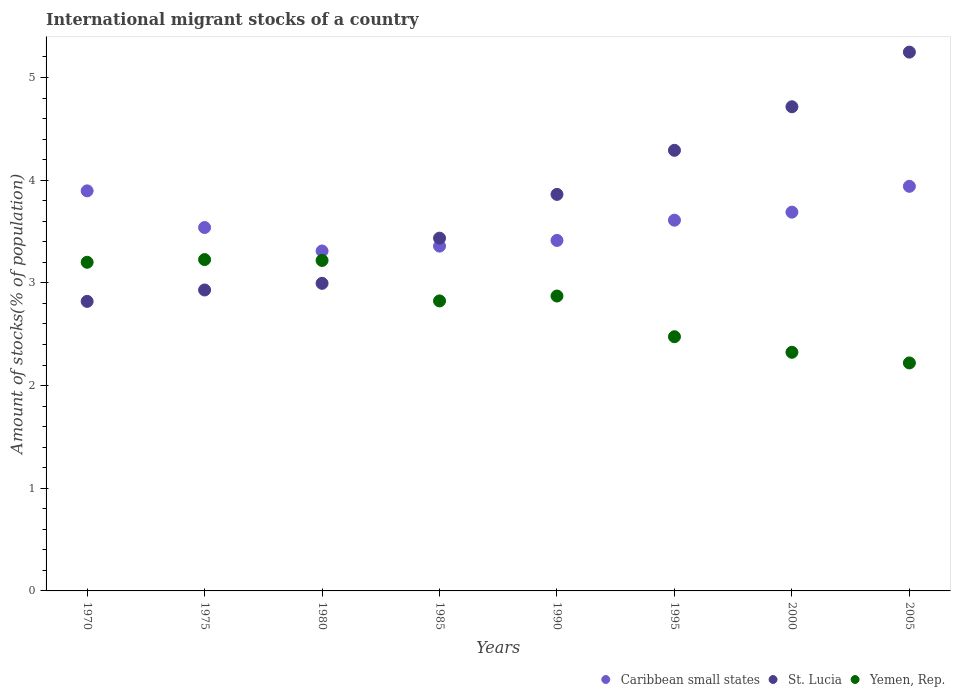How many different coloured dotlines are there?
Offer a terse response. 3. What is the amount of stocks in in Caribbean small states in 1990?
Your answer should be compact. 3.41. Across all years, what is the maximum amount of stocks in in St. Lucia?
Offer a terse response. 5.25. Across all years, what is the minimum amount of stocks in in Yemen, Rep.?
Offer a very short reply. 2.22. In which year was the amount of stocks in in Yemen, Rep. maximum?
Your answer should be very brief. 1975. What is the total amount of stocks in in Caribbean small states in the graph?
Provide a succinct answer. 28.75. What is the difference between the amount of stocks in in Caribbean small states in 1985 and that in 1995?
Your answer should be very brief. -0.25. What is the difference between the amount of stocks in in Caribbean small states in 1985 and the amount of stocks in in St. Lucia in 1980?
Give a very brief answer. 0.36. What is the average amount of stocks in in Caribbean small states per year?
Ensure brevity in your answer.  3.59. In the year 2005, what is the difference between the amount of stocks in in Yemen, Rep. and amount of stocks in in Caribbean small states?
Ensure brevity in your answer.  -1.72. In how many years, is the amount of stocks in in Caribbean small states greater than 1.2 %?
Your answer should be compact. 8. What is the ratio of the amount of stocks in in St. Lucia in 1975 to that in 1985?
Provide a short and direct response. 0.85. Is the amount of stocks in in St. Lucia in 1980 less than that in 2000?
Offer a terse response. Yes. Is the difference between the amount of stocks in in Yemen, Rep. in 2000 and 2005 greater than the difference between the amount of stocks in in Caribbean small states in 2000 and 2005?
Provide a short and direct response. Yes. What is the difference between the highest and the second highest amount of stocks in in Yemen, Rep.?
Your response must be concise. 0.01. What is the difference between the highest and the lowest amount of stocks in in Caribbean small states?
Your response must be concise. 0.63. In how many years, is the amount of stocks in in Yemen, Rep. greater than the average amount of stocks in in Yemen, Rep. taken over all years?
Ensure brevity in your answer.  5. Is the sum of the amount of stocks in in St. Lucia in 1970 and 1990 greater than the maximum amount of stocks in in Yemen, Rep. across all years?
Make the answer very short. Yes. Does the amount of stocks in in St. Lucia monotonically increase over the years?
Keep it short and to the point. Yes. Is the amount of stocks in in St. Lucia strictly less than the amount of stocks in in Yemen, Rep. over the years?
Offer a very short reply. No. How many years are there in the graph?
Offer a very short reply. 8. What is the difference between two consecutive major ticks on the Y-axis?
Your answer should be compact. 1. Are the values on the major ticks of Y-axis written in scientific E-notation?
Your answer should be compact. No. Does the graph contain any zero values?
Your response must be concise. No. Does the graph contain grids?
Offer a terse response. No. Where does the legend appear in the graph?
Provide a short and direct response. Bottom right. What is the title of the graph?
Provide a succinct answer. International migrant stocks of a country. Does "High income: OECD" appear as one of the legend labels in the graph?
Ensure brevity in your answer.  No. What is the label or title of the X-axis?
Offer a very short reply. Years. What is the label or title of the Y-axis?
Provide a succinct answer. Amount of stocks(% of population). What is the Amount of stocks(% of population) in Caribbean small states in 1970?
Provide a short and direct response. 3.9. What is the Amount of stocks(% of population) in St. Lucia in 1970?
Keep it short and to the point. 2.82. What is the Amount of stocks(% of population) in Yemen, Rep. in 1970?
Ensure brevity in your answer.  3.2. What is the Amount of stocks(% of population) in Caribbean small states in 1975?
Your answer should be compact. 3.54. What is the Amount of stocks(% of population) in St. Lucia in 1975?
Give a very brief answer. 2.93. What is the Amount of stocks(% of population) in Yemen, Rep. in 1975?
Your answer should be very brief. 3.23. What is the Amount of stocks(% of population) of Caribbean small states in 1980?
Your answer should be compact. 3.31. What is the Amount of stocks(% of population) of St. Lucia in 1980?
Offer a terse response. 3. What is the Amount of stocks(% of population) of Yemen, Rep. in 1980?
Keep it short and to the point. 3.22. What is the Amount of stocks(% of population) in Caribbean small states in 1985?
Give a very brief answer. 3.36. What is the Amount of stocks(% of population) in St. Lucia in 1985?
Provide a succinct answer. 3.44. What is the Amount of stocks(% of population) in Yemen, Rep. in 1985?
Offer a terse response. 2.82. What is the Amount of stocks(% of population) of Caribbean small states in 1990?
Make the answer very short. 3.41. What is the Amount of stocks(% of population) in St. Lucia in 1990?
Ensure brevity in your answer.  3.86. What is the Amount of stocks(% of population) in Yemen, Rep. in 1990?
Your response must be concise. 2.87. What is the Amount of stocks(% of population) in Caribbean small states in 1995?
Offer a terse response. 3.61. What is the Amount of stocks(% of population) in St. Lucia in 1995?
Ensure brevity in your answer.  4.29. What is the Amount of stocks(% of population) of Yemen, Rep. in 1995?
Your response must be concise. 2.48. What is the Amount of stocks(% of population) of Caribbean small states in 2000?
Make the answer very short. 3.69. What is the Amount of stocks(% of population) of St. Lucia in 2000?
Your answer should be very brief. 4.71. What is the Amount of stocks(% of population) of Yemen, Rep. in 2000?
Provide a succinct answer. 2.32. What is the Amount of stocks(% of population) in Caribbean small states in 2005?
Make the answer very short. 3.94. What is the Amount of stocks(% of population) of St. Lucia in 2005?
Give a very brief answer. 5.25. What is the Amount of stocks(% of population) of Yemen, Rep. in 2005?
Make the answer very short. 2.22. Across all years, what is the maximum Amount of stocks(% of population) of Caribbean small states?
Ensure brevity in your answer.  3.94. Across all years, what is the maximum Amount of stocks(% of population) in St. Lucia?
Offer a very short reply. 5.25. Across all years, what is the maximum Amount of stocks(% of population) in Yemen, Rep.?
Offer a very short reply. 3.23. Across all years, what is the minimum Amount of stocks(% of population) in Caribbean small states?
Offer a very short reply. 3.31. Across all years, what is the minimum Amount of stocks(% of population) in St. Lucia?
Your answer should be very brief. 2.82. Across all years, what is the minimum Amount of stocks(% of population) of Yemen, Rep.?
Ensure brevity in your answer.  2.22. What is the total Amount of stocks(% of population) in Caribbean small states in the graph?
Provide a short and direct response. 28.75. What is the total Amount of stocks(% of population) in St. Lucia in the graph?
Keep it short and to the point. 30.3. What is the total Amount of stocks(% of population) in Yemen, Rep. in the graph?
Make the answer very short. 22.36. What is the difference between the Amount of stocks(% of population) in Caribbean small states in 1970 and that in 1975?
Offer a terse response. 0.36. What is the difference between the Amount of stocks(% of population) in St. Lucia in 1970 and that in 1975?
Provide a succinct answer. -0.11. What is the difference between the Amount of stocks(% of population) in Yemen, Rep. in 1970 and that in 1975?
Keep it short and to the point. -0.03. What is the difference between the Amount of stocks(% of population) in Caribbean small states in 1970 and that in 1980?
Provide a succinct answer. 0.59. What is the difference between the Amount of stocks(% of population) in St. Lucia in 1970 and that in 1980?
Your response must be concise. -0.18. What is the difference between the Amount of stocks(% of population) in Yemen, Rep. in 1970 and that in 1980?
Your answer should be very brief. -0.02. What is the difference between the Amount of stocks(% of population) in Caribbean small states in 1970 and that in 1985?
Keep it short and to the point. 0.54. What is the difference between the Amount of stocks(% of population) in St. Lucia in 1970 and that in 1985?
Give a very brief answer. -0.62. What is the difference between the Amount of stocks(% of population) in Yemen, Rep. in 1970 and that in 1985?
Your answer should be compact. 0.38. What is the difference between the Amount of stocks(% of population) of Caribbean small states in 1970 and that in 1990?
Keep it short and to the point. 0.48. What is the difference between the Amount of stocks(% of population) of St. Lucia in 1970 and that in 1990?
Your answer should be very brief. -1.04. What is the difference between the Amount of stocks(% of population) of Yemen, Rep. in 1970 and that in 1990?
Provide a short and direct response. 0.33. What is the difference between the Amount of stocks(% of population) of Caribbean small states in 1970 and that in 1995?
Offer a very short reply. 0.29. What is the difference between the Amount of stocks(% of population) of St. Lucia in 1970 and that in 1995?
Your answer should be very brief. -1.47. What is the difference between the Amount of stocks(% of population) in Yemen, Rep. in 1970 and that in 1995?
Your answer should be very brief. 0.72. What is the difference between the Amount of stocks(% of population) of Caribbean small states in 1970 and that in 2000?
Offer a very short reply. 0.21. What is the difference between the Amount of stocks(% of population) in St. Lucia in 1970 and that in 2000?
Offer a very short reply. -1.9. What is the difference between the Amount of stocks(% of population) of Yemen, Rep. in 1970 and that in 2000?
Your answer should be compact. 0.88. What is the difference between the Amount of stocks(% of population) in Caribbean small states in 1970 and that in 2005?
Give a very brief answer. -0.04. What is the difference between the Amount of stocks(% of population) in St. Lucia in 1970 and that in 2005?
Give a very brief answer. -2.43. What is the difference between the Amount of stocks(% of population) of Yemen, Rep. in 1970 and that in 2005?
Provide a succinct answer. 0.98. What is the difference between the Amount of stocks(% of population) of Caribbean small states in 1975 and that in 1980?
Provide a short and direct response. 0.23. What is the difference between the Amount of stocks(% of population) of St. Lucia in 1975 and that in 1980?
Your answer should be very brief. -0.06. What is the difference between the Amount of stocks(% of population) in Yemen, Rep. in 1975 and that in 1980?
Give a very brief answer. 0.01. What is the difference between the Amount of stocks(% of population) in Caribbean small states in 1975 and that in 1985?
Provide a succinct answer. 0.18. What is the difference between the Amount of stocks(% of population) in St. Lucia in 1975 and that in 1985?
Keep it short and to the point. -0.5. What is the difference between the Amount of stocks(% of population) in Yemen, Rep. in 1975 and that in 1985?
Keep it short and to the point. 0.4. What is the difference between the Amount of stocks(% of population) in Caribbean small states in 1975 and that in 1990?
Offer a terse response. 0.13. What is the difference between the Amount of stocks(% of population) of St. Lucia in 1975 and that in 1990?
Offer a very short reply. -0.93. What is the difference between the Amount of stocks(% of population) of Yemen, Rep. in 1975 and that in 1990?
Provide a succinct answer. 0.35. What is the difference between the Amount of stocks(% of population) of Caribbean small states in 1975 and that in 1995?
Your answer should be very brief. -0.07. What is the difference between the Amount of stocks(% of population) in St. Lucia in 1975 and that in 1995?
Provide a succinct answer. -1.36. What is the difference between the Amount of stocks(% of population) of Yemen, Rep. in 1975 and that in 1995?
Provide a succinct answer. 0.75. What is the difference between the Amount of stocks(% of population) of Caribbean small states in 1975 and that in 2000?
Your response must be concise. -0.15. What is the difference between the Amount of stocks(% of population) in St. Lucia in 1975 and that in 2000?
Keep it short and to the point. -1.78. What is the difference between the Amount of stocks(% of population) in Yemen, Rep. in 1975 and that in 2000?
Your answer should be very brief. 0.9. What is the difference between the Amount of stocks(% of population) in Caribbean small states in 1975 and that in 2005?
Offer a terse response. -0.4. What is the difference between the Amount of stocks(% of population) in St. Lucia in 1975 and that in 2005?
Make the answer very short. -2.32. What is the difference between the Amount of stocks(% of population) in Yemen, Rep. in 1975 and that in 2005?
Your answer should be compact. 1.01. What is the difference between the Amount of stocks(% of population) of Caribbean small states in 1980 and that in 1985?
Your response must be concise. -0.05. What is the difference between the Amount of stocks(% of population) of St. Lucia in 1980 and that in 1985?
Provide a succinct answer. -0.44. What is the difference between the Amount of stocks(% of population) of Yemen, Rep. in 1980 and that in 1985?
Give a very brief answer. 0.39. What is the difference between the Amount of stocks(% of population) in Caribbean small states in 1980 and that in 1990?
Offer a terse response. -0.1. What is the difference between the Amount of stocks(% of population) in St. Lucia in 1980 and that in 1990?
Your answer should be compact. -0.87. What is the difference between the Amount of stocks(% of population) of Yemen, Rep. in 1980 and that in 1990?
Your answer should be compact. 0.35. What is the difference between the Amount of stocks(% of population) in Caribbean small states in 1980 and that in 1995?
Offer a very short reply. -0.3. What is the difference between the Amount of stocks(% of population) of St. Lucia in 1980 and that in 1995?
Your answer should be very brief. -1.3. What is the difference between the Amount of stocks(% of population) in Yemen, Rep. in 1980 and that in 1995?
Make the answer very short. 0.74. What is the difference between the Amount of stocks(% of population) of Caribbean small states in 1980 and that in 2000?
Your answer should be very brief. -0.38. What is the difference between the Amount of stocks(% of population) of St. Lucia in 1980 and that in 2000?
Provide a short and direct response. -1.72. What is the difference between the Amount of stocks(% of population) of Yemen, Rep. in 1980 and that in 2000?
Your answer should be very brief. 0.89. What is the difference between the Amount of stocks(% of population) in Caribbean small states in 1980 and that in 2005?
Offer a very short reply. -0.63. What is the difference between the Amount of stocks(% of population) in St. Lucia in 1980 and that in 2005?
Offer a terse response. -2.25. What is the difference between the Amount of stocks(% of population) of Yemen, Rep. in 1980 and that in 2005?
Give a very brief answer. 1. What is the difference between the Amount of stocks(% of population) of Caribbean small states in 1985 and that in 1990?
Ensure brevity in your answer.  -0.06. What is the difference between the Amount of stocks(% of population) of St. Lucia in 1985 and that in 1990?
Your response must be concise. -0.43. What is the difference between the Amount of stocks(% of population) in Yemen, Rep. in 1985 and that in 1990?
Your answer should be very brief. -0.05. What is the difference between the Amount of stocks(% of population) of Caribbean small states in 1985 and that in 1995?
Give a very brief answer. -0.25. What is the difference between the Amount of stocks(% of population) of St. Lucia in 1985 and that in 1995?
Make the answer very short. -0.86. What is the difference between the Amount of stocks(% of population) in Yemen, Rep. in 1985 and that in 1995?
Give a very brief answer. 0.35. What is the difference between the Amount of stocks(% of population) of Caribbean small states in 1985 and that in 2000?
Your answer should be compact. -0.33. What is the difference between the Amount of stocks(% of population) of St. Lucia in 1985 and that in 2000?
Give a very brief answer. -1.28. What is the difference between the Amount of stocks(% of population) in Yemen, Rep. in 1985 and that in 2000?
Your answer should be compact. 0.5. What is the difference between the Amount of stocks(% of population) of Caribbean small states in 1985 and that in 2005?
Give a very brief answer. -0.58. What is the difference between the Amount of stocks(% of population) in St. Lucia in 1985 and that in 2005?
Keep it short and to the point. -1.81. What is the difference between the Amount of stocks(% of population) of Yemen, Rep. in 1985 and that in 2005?
Give a very brief answer. 0.6. What is the difference between the Amount of stocks(% of population) in Caribbean small states in 1990 and that in 1995?
Offer a very short reply. -0.2. What is the difference between the Amount of stocks(% of population) of St. Lucia in 1990 and that in 1995?
Give a very brief answer. -0.43. What is the difference between the Amount of stocks(% of population) of Yemen, Rep. in 1990 and that in 1995?
Keep it short and to the point. 0.4. What is the difference between the Amount of stocks(% of population) of Caribbean small states in 1990 and that in 2000?
Keep it short and to the point. -0.28. What is the difference between the Amount of stocks(% of population) of St. Lucia in 1990 and that in 2000?
Provide a succinct answer. -0.85. What is the difference between the Amount of stocks(% of population) of Yemen, Rep. in 1990 and that in 2000?
Your answer should be compact. 0.55. What is the difference between the Amount of stocks(% of population) in Caribbean small states in 1990 and that in 2005?
Offer a very short reply. -0.53. What is the difference between the Amount of stocks(% of population) in St. Lucia in 1990 and that in 2005?
Your response must be concise. -1.39. What is the difference between the Amount of stocks(% of population) of Yemen, Rep. in 1990 and that in 2005?
Provide a succinct answer. 0.65. What is the difference between the Amount of stocks(% of population) of Caribbean small states in 1995 and that in 2000?
Give a very brief answer. -0.08. What is the difference between the Amount of stocks(% of population) of St. Lucia in 1995 and that in 2000?
Make the answer very short. -0.42. What is the difference between the Amount of stocks(% of population) of Yemen, Rep. in 1995 and that in 2000?
Provide a succinct answer. 0.15. What is the difference between the Amount of stocks(% of population) of Caribbean small states in 1995 and that in 2005?
Provide a short and direct response. -0.33. What is the difference between the Amount of stocks(% of population) of St. Lucia in 1995 and that in 2005?
Offer a terse response. -0.96. What is the difference between the Amount of stocks(% of population) of Yemen, Rep. in 1995 and that in 2005?
Make the answer very short. 0.26. What is the difference between the Amount of stocks(% of population) of Caribbean small states in 2000 and that in 2005?
Provide a short and direct response. -0.25. What is the difference between the Amount of stocks(% of population) in St. Lucia in 2000 and that in 2005?
Your answer should be compact. -0.53. What is the difference between the Amount of stocks(% of population) of Yemen, Rep. in 2000 and that in 2005?
Your answer should be compact. 0.1. What is the difference between the Amount of stocks(% of population) of Caribbean small states in 1970 and the Amount of stocks(% of population) of St. Lucia in 1975?
Give a very brief answer. 0.97. What is the difference between the Amount of stocks(% of population) of Caribbean small states in 1970 and the Amount of stocks(% of population) of Yemen, Rep. in 1975?
Make the answer very short. 0.67. What is the difference between the Amount of stocks(% of population) of St. Lucia in 1970 and the Amount of stocks(% of population) of Yemen, Rep. in 1975?
Offer a terse response. -0.41. What is the difference between the Amount of stocks(% of population) of Caribbean small states in 1970 and the Amount of stocks(% of population) of St. Lucia in 1980?
Make the answer very short. 0.9. What is the difference between the Amount of stocks(% of population) in Caribbean small states in 1970 and the Amount of stocks(% of population) in Yemen, Rep. in 1980?
Your answer should be compact. 0.68. What is the difference between the Amount of stocks(% of population) in St. Lucia in 1970 and the Amount of stocks(% of population) in Yemen, Rep. in 1980?
Your answer should be very brief. -0.4. What is the difference between the Amount of stocks(% of population) of Caribbean small states in 1970 and the Amount of stocks(% of population) of St. Lucia in 1985?
Provide a short and direct response. 0.46. What is the difference between the Amount of stocks(% of population) of Caribbean small states in 1970 and the Amount of stocks(% of population) of Yemen, Rep. in 1985?
Provide a succinct answer. 1.07. What is the difference between the Amount of stocks(% of population) in St. Lucia in 1970 and the Amount of stocks(% of population) in Yemen, Rep. in 1985?
Your response must be concise. -0. What is the difference between the Amount of stocks(% of population) in Caribbean small states in 1970 and the Amount of stocks(% of population) in St. Lucia in 1990?
Your response must be concise. 0.03. What is the difference between the Amount of stocks(% of population) of Caribbean small states in 1970 and the Amount of stocks(% of population) of Yemen, Rep. in 1990?
Give a very brief answer. 1.02. What is the difference between the Amount of stocks(% of population) of St. Lucia in 1970 and the Amount of stocks(% of population) of Yemen, Rep. in 1990?
Make the answer very short. -0.05. What is the difference between the Amount of stocks(% of population) in Caribbean small states in 1970 and the Amount of stocks(% of population) in St. Lucia in 1995?
Offer a very short reply. -0.39. What is the difference between the Amount of stocks(% of population) in Caribbean small states in 1970 and the Amount of stocks(% of population) in Yemen, Rep. in 1995?
Your answer should be very brief. 1.42. What is the difference between the Amount of stocks(% of population) of St. Lucia in 1970 and the Amount of stocks(% of population) of Yemen, Rep. in 1995?
Provide a succinct answer. 0.34. What is the difference between the Amount of stocks(% of population) in Caribbean small states in 1970 and the Amount of stocks(% of population) in St. Lucia in 2000?
Make the answer very short. -0.82. What is the difference between the Amount of stocks(% of population) in Caribbean small states in 1970 and the Amount of stocks(% of population) in Yemen, Rep. in 2000?
Offer a very short reply. 1.57. What is the difference between the Amount of stocks(% of population) in St. Lucia in 1970 and the Amount of stocks(% of population) in Yemen, Rep. in 2000?
Keep it short and to the point. 0.5. What is the difference between the Amount of stocks(% of population) in Caribbean small states in 1970 and the Amount of stocks(% of population) in St. Lucia in 2005?
Your response must be concise. -1.35. What is the difference between the Amount of stocks(% of population) in Caribbean small states in 1970 and the Amount of stocks(% of population) in Yemen, Rep. in 2005?
Make the answer very short. 1.68. What is the difference between the Amount of stocks(% of population) of St. Lucia in 1970 and the Amount of stocks(% of population) of Yemen, Rep. in 2005?
Your response must be concise. 0.6. What is the difference between the Amount of stocks(% of population) of Caribbean small states in 1975 and the Amount of stocks(% of population) of St. Lucia in 1980?
Give a very brief answer. 0.54. What is the difference between the Amount of stocks(% of population) in Caribbean small states in 1975 and the Amount of stocks(% of population) in Yemen, Rep. in 1980?
Your answer should be compact. 0.32. What is the difference between the Amount of stocks(% of population) in St. Lucia in 1975 and the Amount of stocks(% of population) in Yemen, Rep. in 1980?
Offer a terse response. -0.29. What is the difference between the Amount of stocks(% of population) in Caribbean small states in 1975 and the Amount of stocks(% of population) in St. Lucia in 1985?
Ensure brevity in your answer.  0.1. What is the difference between the Amount of stocks(% of population) in Caribbean small states in 1975 and the Amount of stocks(% of population) in Yemen, Rep. in 1985?
Your answer should be compact. 0.71. What is the difference between the Amount of stocks(% of population) of St. Lucia in 1975 and the Amount of stocks(% of population) of Yemen, Rep. in 1985?
Make the answer very short. 0.11. What is the difference between the Amount of stocks(% of population) of Caribbean small states in 1975 and the Amount of stocks(% of population) of St. Lucia in 1990?
Ensure brevity in your answer.  -0.32. What is the difference between the Amount of stocks(% of population) in Caribbean small states in 1975 and the Amount of stocks(% of population) in Yemen, Rep. in 1990?
Your answer should be compact. 0.67. What is the difference between the Amount of stocks(% of population) in St. Lucia in 1975 and the Amount of stocks(% of population) in Yemen, Rep. in 1990?
Offer a very short reply. 0.06. What is the difference between the Amount of stocks(% of population) in Caribbean small states in 1975 and the Amount of stocks(% of population) in St. Lucia in 1995?
Provide a succinct answer. -0.75. What is the difference between the Amount of stocks(% of population) of Caribbean small states in 1975 and the Amount of stocks(% of population) of Yemen, Rep. in 1995?
Your answer should be compact. 1.06. What is the difference between the Amount of stocks(% of population) in St. Lucia in 1975 and the Amount of stocks(% of population) in Yemen, Rep. in 1995?
Give a very brief answer. 0.46. What is the difference between the Amount of stocks(% of population) in Caribbean small states in 1975 and the Amount of stocks(% of population) in St. Lucia in 2000?
Provide a short and direct response. -1.18. What is the difference between the Amount of stocks(% of population) in Caribbean small states in 1975 and the Amount of stocks(% of population) in Yemen, Rep. in 2000?
Provide a succinct answer. 1.22. What is the difference between the Amount of stocks(% of population) in St. Lucia in 1975 and the Amount of stocks(% of population) in Yemen, Rep. in 2000?
Keep it short and to the point. 0.61. What is the difference between the Amount of stocks(% of population) in Caribbean small states in 1975 and the Amount of stocks(% of population) in St. Lucia in 2005?
Provide a short and direct response. -1.71. What is the difference between the Amount of stocks(% of population) of Caribbean small states in 1975 and the Amount of stocks(% of population) of Yemen, Rep. in 2005?
Make the answer very short. 1.32. What is the difference between the Amount of stocks(% of population) of St. Lucia in 1975 and the Amount of stocks(% of population) of Yemen, Rep. in 2005?
Give a very brief answer. 0.71. What is the difference between the Amount of stocks(% of population) of Caribbean small states in 1980 and the Amount of stocks(% of population) of St. Lucia in 1985?
Provide a succinct answer. -0.13. What is the difference between the Amount of stocks(% of population) of Caribbean small states in 1980 and the Amount of stocks(% of population) of Yemen, Rep. in 1985?
Offer a terse response. 0.49. What is the difference between the Amount of stocks(% of population) of St. Lucia in 1980 and the Amount of stocks(% of population) of Yemen, Rep. in 1985?
Your answer should be very brief. 0.17. What is the difference between the Amount of stocks(% of population) in Caribbean small states in 1980 and the Amount of stocks(% of population) in St. Lucia in 1990?
Provide a short and direct response. -0.55. What is the difference between the Amount of stocks(% of population) of Caribbean small states in 1980 and the Amount of stocks(% of population) of Yemen, Rep. in 1990?
Give a very brief answer. 0.44. What is the difference between the Amount of stocks(% of population) in St. Lucia in 1980 and the Amount of stocks(% of population) in Yemen, Rep. in 1990?
Provide a short and direct response. 0.12. What is the difference between the Amount of stocks(% of population) of Caribbean small states in 1980 and the Amount of stocks(% of population) of St. Lucia in 1995?
Give a very brief answer. -0.98. What is the difference between the Amount of stocks(% of population) of Caribbean small states in 1980 and the Amount of stocks(% of population) of Yemen, Rep. in 1995?
Ensure brevity in your answer.  0.83. What is the difference between the Amount of stocks(% of population) of St. Lucia in 1980 and the Amount of stocks(% of population) of Yemen, Rep. in 1995?
Your answer should be very brief. 0.52. What is the difference between the Amount of stocks(% of population) of Caribbean small states in 1980 and the Amount of stocks(% of population) of St. Lucia in 2000?
Your answer should be compact. -1.4. What is the difference between the Amount of stocks(% of population) in Caribbean small states in 1980 and the Amount of stocks(% of population) in Yemen, Rep. in 2000?
Provide a short and direct response. 0.99. What is the difference between the Amount of stocks(% of population) of St. Lucia in 1980 and the Amount of stocks(% of population) of Yemen, Rep. in 2000?
Make the answer very short. 0.67. What is the difference between the Amount of stocks(% of population) of Caribbean small states in 1980 and the Amount of stocks(% of population) of St. Lucia in 2005?
Your answer should be very brief. -1.94. What is the difference between the Amount of stocks(% of population) of Caribbean small states in 1980 and the Amount of stocks(% of population) of Yemen, Rep. in 2005?
Offer a terse response. 1.09. What is the difference between the Amount of stocks(% of population) in St. Lucia in 1980 and the Amount of stocks(% of population) in Yemen, Rep. in 2005?
Offer a very short reply. 0.78. What is the difference between the Amount of stocks(% of population) in Caribbean small states in 1985 and the Amount of stocks(% of population) in St. Lucia in 1990?
Provide a succinct answer. -0.5. What is the difference between the Amount of stocks(% of population) in Caribbean small states in 1985 and the Amount of stocks(% of population) in Yemen, Rep. in 1990?
Keep it short and to the point. 0.49. What is the difference between the Amount of stocks(% of population) in St. Lucia in 1985 and the Amount of stocks(% of population) in Yemen, Rep. in 1990?
Provide a succinct answer. 0.56. What is the difference between the Amount of stocks(% of population) in Caribbean small states in 1985 and the Amount of stocks(% of population) in St. Lucia in 1995?
Provide a short and direct response. -0.93. What is the difference between the Amount of stocks(% of population) in Caribbean small states in 1985 and the Amount of stocks(% of population) in Yemen, Rep. in 1995?
Keep it short and to the point. 0.88. What is the difference between the Amount of stocks(% of population) of Caribbean small states in 1985 and the Amount of stocks(% of population) of St. Lucia in 2000?
Offer a very short reply. -1.36. What is the difference between the Amount of stocks(% of population) in Caribbean small states in 1985 and the Amount of stocks(% of population) in Yemen, Rep. in 2000?
Give a very brief answer. 1.03. What is the difference between the Amount of stocks(% of population) in St. Lucia in 1985 and the Amount of stocks(% of population) in Yemen, Rep. in 2000?
Offer a very short reply. 1.11. What is the difference between the Amount of stocks(% of population) of Caribbean small states in 1985 and the Amount of stocks(% of population) of St. Lucia in 2005?
Make the answer very short. -1.89. What is the difference between the Amount of stocks(% of population) in Caribbean small states in 1985 and the Amount of stocks(% of population) in Yemen, Rep. in 2005?
Provide a succinct answer. 1.14. What is the difference between the Amount of stocks(% of population) in St. Lucia in 1985 and the Amount of stocks(% of population) in Yemen, Rep. in 2005?
Your response must be concise. 1.22. What is the difference between the Amount of stocks(% of population) of Caribbean small states in 1990 and the Amount of stocks(% of population) of St. Lucia in 1995?
Offer a terse response. -0.88. What is the difference between the Amount of stocks(% of population) of Caribbean small states in 1990 and the Amount of stocks(% of population) of Yemen, Rep. in 1995?
Provide a short and direct response. 0.94. What is the difference between the Amount of stocks(% of population) of St. Lucia in 1990 and the Amount of stocks(% of population) of Yemen, Rep. in 1995?
Ensure brevity in your answer.  1.39. What is the difference between the Amount of stocks(% of population) of Caribbean small states in 1990 and the Amount of stocks(% of population) of St. Lucia in 2000?
Offer a very short reply. -1.3. What is the difference between the Amount of stocks(% of population) of Caribbean small states in 1990 and the Amount of stocks(% of population) of Yemen, Rep. in 2000?
Provide a short and direct response. 1.09. What is the difference between the Amount of stocks(% of population) of St. Lucia in 1990 and the Amount of stocks(% of population) of Yemen, Rep. in 2000?
Provide a succinct answer. 1.54. What is the difference between the Amount of stocks(% of population) in Caribbean small states in 1990 and the Amount of stocks(% of population) in St. Lucia in 2005?
Your response must be concise. -1.83. What is the difference between the Amount of stocks(% of population) in Caribbean small states in 1990 and the Amount of stocks(% of population) in Yemen, Rep. in 2005?
Offer a very short reply. 1.19. What is the difference between the Amount of stocks(% of population) in St. Lucia in 1990 and the Amount of stocks(% of population) in Yemen, Rep. in 2005?
Give a very brief answer. 1.64. What is the difference between the Amount of stocks(% of population) of Caribbean small states in 1995 and the Amount of stocks(% of population) of St. Lucia in 2000?
Give a very brief answer. -1.1. What is the difference between the Amount of stocks(% of population) of Caribbean small states in 1995 and the Amount of stocks(% of population) of Yemen, Rep. in 2000?
Ensure brevity in your answer.  1.29. What is the difference between the Amount of stocks(% of population) of St. Lucia in 1995 and the Amount of stocks(% of population) of Yemen, Rep. in 2000?
Ensure brevity in your answer.  1.97. What is the difference between the Amount of stocks(% of population) of Caribbean small states in 1995 and the Amount of stocks(% of population) of St. Lucia in 2005?
Offer a terse response. -1.64. What is the difference between the Amount of stocks(% of population) of Caribbean small states in 1995 and the Amount of stocks(% of population) of Yemen, Rep. in 2005?
Provide a succinct answer. 1.39. What is the difference between the Amount of stocks(% of population) in St. Lucia in 1995 and the Amount of stocks(% of population) in Yemen, Rep. in 2005?
Your response must be concise. 2.07. What is the difference between the Amount of stocks(% of population) in Caribbean small states in 2000 and the Amount of stocks(% of population) in St. Lucia in 2005?
Provide a succinct answer. -1.56. What is the difference between the Amount of stocks(% of population) of Caribbean small states in 2000 and the Amount of stocks(% of population) of Yemen, Rep. in 2005?
Make the answer very short. 1.47. What is the difference between the Amount of stocks(% of population) of St. Lucia in 2000 and the Amount of stocks(% of population) of Yemen, Rep. in 2005?
Provide a succinct answer. 2.49. What is the average Amount of stocks(% of population) of Caribbean small states per year?
Make the answer very short. 3.59. What is the average Amount of stocks(% of population) of St. Lucia per year?
Make the answer very short. 3.79. What is the average Amount of stocks(% of population) in Yemen, Rep. per year?
Provide a succinct answer. 2.8. In the year 1970, what is the difference between the Amount of stocks(% of population) of Caribbean small states and Amount of stocks(% of population) of St. Lucia?
Your response must be concise. 1.08. In the year 1970, what is the difference between the Amount of stocks(% of population) of Caribbean small states and Amount of stocks(% of population) of Yemen, Rep.?
Give a very brief answer. 0.7. In the year 1970, what is the difference between the Amount of stocks(% of population) of St. Lucia and Amount of stocks(% of population) of Yemen, Rep.?
Provide a succinct answer. -0.38. In the year 1975, what is the difference between the Amount of stocks(% of population) of Caribbean small states and Amount of stocks(% of population) of St. Lucia?
Your answer should be very brief. 0.61. In the year 1975, what is the difference between the Amount of stocks(% of population) in Caribbean small states and Amount of stocks(% of population) in Yemen, Rep.?
Provide a short and direct response. 0.31. In the year 1975, what is the difference between the Amount of stocks(% of population) of St. Lucia and Amount of stocks(% of population) of Yemen, Rep.?
Offer a very short reply. -0.3. In the year 1980, what is the difference between the Amount of stocks(% of population) in Caribbean small states and Amount of stocks(% of population) in St. Lucia?
Offer a terse response. 0.32. In the year 1980, what is the difference between the Amount of stocks(% of population) in Caribbean small states and Amount of stocks(% of population) in Yemen, Rep.?
Provide a succinct answer. 0.09. In the year 1980, what is the difference between the Amount of stocks(% of population) in St. Lucia and Amount of stocks(% of population) in Yemen, Rep.?
Give a very brief answer. -0.22. In the year 1985, what is the difference between the Amount of stocks(% of population) of Caribbean small states and Amount of stocks(% of population) of St. Lucia?
Give a very brief answer. -0.08. In the year 1985, what is the difference between the Amount of stocks(% of population) of Caribbean small states and Amount of stocks(% of population) of Yemen, Rep.?
Ensure brevity in your answer.  0.53. In the year 1985, what is the difference between the Amount of stocks(% of population) in St. Lucia and Amount of stocks(% of population) in Yemen, Rep.?
Provide a succinct answer. 0.61. In the year 1990, what is the difference between the Amount of stocks(% of population) of Caribbean small states and Amount of stocks(% of population) of St. Lucia?
Give a very brief answer. -0.45. In the year 1990, what is the difference between the Amount of stocks(% of population) of Caribbean small states and Amount of stocks(% of population) of Yemen, Rep.?
Your response must be concise. 0.54. In the year 1990, what is the difference between the Amount of stocks(% of population) in St. Lucia and Amount of stocks(% of population) in Yemen, Rep.?
Ensure brevity in your answer.  0.99. In the year 1995, what is the difference between the Amount of stocks(% of population) in Caribbean small states and Amount of stocks(% of population) in St. Lucia?
Provide a succinct answer. -0.68. In the year 1995, what is the difference between the Amount of stocks(% of population) in Caribbean small states and Amount of stocks(% of population) in Yemen, Rep.?
Your answer should be very brief. 1.13. In the year 1995, what is the difference between the Amount of stocks(% of population) of St. Lucia and Amount of stocks(% of population) of Yemen, Rep.?
Offer a very short reply. 1.82. In the year 2000, what is the difference between the Amount of stocks(% of population) of Caribbean small states and Amount of stocks(% of population) of St. Lucia?
Provide a short and direct response. -1.03. In the year 2000, what is the difference between the Amount of stocks(% of population) in Caribbean small states and Amount of stocks(% of population) in Yemen, Rep.?
Your answer should be compact. 1.36. In the year 2000, what is the difference between the Amount of stocks(% of population) in St. Lucia and Amount of stocks(% of population) in Yemen, Rep.?
Make the answer very short. 2.39. In the year 2005, what is the difference between the Amount of stocks(% of population) of Caribbean small states and Amount of stocks(% of population) of St. Lucia?
Your response must be concise. -1.31. In the year 2005, what is the difference between the Amount of stocks(% of population) in Caribbean small states and Amount of stocks(% of population) in Yemen, Rep.?
Your response must be concise. 1.72. In the year 2005, what is the difference between the Amount of stocks(% of population) in St. Lucia and Amount of stocks(% of population) in Yemen, Rep.?
Your response must be concise. 3.03. What is the ratio of the Amount of stocks(% of population) in Caribbean small states in 1970 to that in 1975?
Your response must be concise. 1.1. What is the ratio of the Amount of stocks(% of population) in St. Lucia in 1970 to that in 1975?
Give a very brief answer. 0.96. What is the ratio of the Amount of stocks(% of population) in Caribbean small states in 1970 to that in 1980?
Make the answer very short. 1.18. What is the ratio of the Amount of stocks(% of population) of St. Lucia in 1970 to that in 1980?
Provide a short and direct response. 0.94. What is the ratio of the Amount of stocks(% of population) in Yemen, Rep. in 1970 to that in 1980?
Give a very brief answer. 0.99. What is the ratio of the Amount of stocks(% of population) of Caribbean small states in 1970 to that in 1985?
Offer a very short reply. 1.16. What is the ratio of the Amount of stocks(% of population) in St. Lucia in 1970 to that in 1985?
Provide a succinct answer. 0.82. What is the ratio of the Amount of stocks(% of population) of Yemen, Rep. in 1970 to that in 1985?
Your response must be concise. 1.13. What is the ratio of the Amount of stocks(% of population) of Caribbean small states in 1970 to that in 1990?
Provide a succinct answer. 1.14. What is the ratio of the Amount of stocks(% of population) of St. Lucia in 1970 to that in 1990?
Your answer should be very brief. 0.73. What is the ratio of the Amount of stocks(% of population) of Yemen, Rep. in 1970 to that in 1990?
Your response must be concise. 1.11. What is the ratio of the Amount of stocks(% of population) of Caribbean small states in 1970 to that in 1995?
Provide a succinct answer. 1.08. What is the ratio of the Amount of stocks(% of population) of St. Lucia in 1970 to that in 1995?
Offer a terse response. 0.66. What is the ratio of the Amount of stocks(% of population) of Yemen, Rep. in 1970 to that in 1995?
Offer a very short reply. 1.29. What is the ratio of the Amount of stocks(% of population) of Caribbean small states in 1970 to that in 2000?
Your answer should be very brief. 1.06. What is the ratio of the Amount of stocks(% of population) in St. Lucia in 1970 to that in 2000?
Make the answer very short. 0.6. What is the ratio of the Amount of stocks(% of population) in Yemen, Rep. in 1970 to that in 2000?
Your answer should be very brief. 1.38. What is the ratio of the Amount of stocks(% of population) in Caribbean small states in 1970 to that in 2005?
Provide a short and direct response. 0.99. What is the ratio of the Amount of stocks(% of population) in St. Lucia in 1970 to that in 2005?
Your answer should be compact. 0.54. What is the ratio of the Amount of stocks(% of population) of Yemen, Rep. in 1970 to that in 2005?
Provide a short and direct response. 1.44. What is the ratio of the Amount of stocks(% of population) of Caribbean small states in 1975 to that in 1980?
Provide a short and direct response. 1.07. What is the ratio of the Amount of stocks(% of population) of St. Lucia in 1975 to that in 1980?
Make the answer very short. 0.98. What is the ratio of the Amount of stocks(% of population) of Caribbean small states in 1975 to that in 1985?
Ensure brevity in your answer.  1.05. What is the ratio of the Amount of stocks(% of population) of St. Lucia in 1975 to that in 1985?
Provide a short and direct response. 0.85. What is the ratio of the Amount of stocks(% of population) in Yemen, Rep. in 1975 to that in 1985?
Give a very brief answer. 1.14. What is the ratio of the Amount of stocks(% of population) in Caribbean small states in 1975 to that in 1990?
Provide a succinct answer. 1.04. What is the ratio of the Amount of stocks(% of population) of St. Lucia in 1975 to that in 1990?
Your answer should be very brief. 0.76. What is the ratio of the Amount of stocks(% of population) of Yemen, Rep. in 1975 to that in 1990?
Keep it short and to the point. 1.12. What is the ratio of the Amount of stocks(% of population) in Caribbean small states in 1975 to that in 1995?
Give a very brief answer. 0.98. What is the ratio of the Amount of stocks(% of population) in St. Lucia in 1975 to that in 1995?
Make the answer very short. 0.68. What is the ratio of the Amount of stocks(% of population) of Yemen, Rep. in 1975 to that in 1995?
Make the answer very short. 1.3. What is the ratio of the Amount of stocks(% of population) of Caribbean small states in 1975 to that in 2000?
Offer a very short reply. 0.96. What is the ratio of the Amount of stocks(% of population) in St. Lucia in 1975 to that in 2000?
Provide a succinct answer. 0.62. What is the ratio of the Amount of stocks(% of population) of Yemen, Rep. in 1975 to that in 2000?
Your answer should be compact. 1.39. What is the ratio of the Amount of stocks(% of population) of Caribbean small states in 1975 to that in 2005?
Your answer should be compact. 0.9. What is the ratio of the Amount of stocks(% of population) in St. Lucia in 1975 to that in 2005?
Keep it short and to the point. 0.56. What is the ratio of the Amount of stocks(% of population) in Yemen, Rep. in 1975 to that in 2005?
Keep it short and to the point. 1.45. What is the ratio of the Amount of stocks(% of population) in Caribbean small states in 1980 to that in 1985?
Ensure brevity in your answer.  0.99. What is the ratio of the Amount of stocks(% of population) of St. Lucia in 1980 to that in 1985?
Give a very brief answer. 0.87. What is the ratio of the Amount of stocks(% of population) of Yemen, Rep. in 1980 to that in 1985?
Offer a terse response. 1.14. What is the ratio of the Amount of stocks(% of population) in Caribbean small states in 1980 to that in 1990?
Give a very brief answer. 0.97. What is the ratio of the Amount of stocks(% of population) in St. Lucia in 1980 to that in 1990?
Keep it short and to the point. 0.78. What is the ratio of the Amount of stocks(% of population) in Yemen, Rep. in 1980 to that in 1990?
Provide a succinct answer. 1.12. What is the ratio of the Amount of stocks(% of population) of Caribbean small states in 1980 to that in 1995?
Offer a terse response. 0.92. What is the ratio of the Amount of stocks(% of population) of St. Lucia in 1980 to that in 1995?
Your response must be concise. 0.7. What is the ratio of the Amount of stocks(% of population) in Yemen, Rep. in 1980 to that in 1995?
Make the answer very short. 1.3. What is the ratio of the Amount of stocks(% of population) of Caribbean small states in 1980 to that in 2000?
Make the answer very short. 0.9. What is the ratio of the Amount of stocks(% of population) in St. Lucia in 1980 to that in 2000?
Offer a terse response. 0.64. What is the ratio of the Amount of stocks(% of population) of Yemen, Rep. in 1980 to that in 2000?
Provide a short and direct response. 1.38. What is the ratio of the Amount of stocks(% of population) of Caribbean small states in 1980 to that in 2005?
Offer a very short reply. 0.84. What is the ratio of the Amount of stocks(% of population) in St. Lucia in 1980 to that in 2005?
Give a very brief answer. 0.57. What is the ratio of the Amount of stocks(% of population) in Yemen, Rep. in 1980 to that in 2005?
Ensure brevity in your answer.  1.45. What is the ratio of the Amount of stocks(% of population) of Caribbean small states in 1985 to that in 1990?
Offer a terse response. 0.98. What is the ratio of the Amount of stocks(% of population) of St. Lucia in 1985 to that in 1990?
Ensure brevity in your answer.  0.89. What is the ratio of the Amount of stocks(% of population) in Yemen, Rep. in 1985 to that in 1990?
Give a very brief answer. 0.98. What is the ratio of the Amount of stocks(% of population) in Caribbean small states in 1985 to that in 1995?
Make the answer very short. 0.93. What is the ratio of the Amount of stocks(% of population) of St. Lucia in 1985 to that in 1995?
Ensure brevity in your answer.  0.8. What is the ratio of the Amount of stocks(% of population) in Yemen, Rep. in 1985 to that in 1995?
Give a very brief answer. 1.14. What is the ratio of the Amount of stocks(% of population) of Caribbean small states in 1985 to that in 2000?
Your answer should be compact. 0.91. What is the ratio of the Amount of stocks(% of population) of St. Lucia in 1985 to that in 2000?
Provide a short and direct response. 0.73. What is the ratio of the Amount of stocks(% of population) in Yemen, Rep. in 1985 to that in 2000?
Your answer should be very brief. 1.22. What is the ratio of the Amount of stocks(% of population) of Caribbean small states in 1985 to that in 2005?
Keep it short and to the point. 0.85. What is the ratio of the Amount of stocks(% of population) of St. Lucia in 1985 to that in 2005?
Offer a terse response. 0.65. What is the ratio of the Amount of stocks(% of population) in Yemen, Rep. in 1985 to that in 2005?
Keep it short and to the point. 1.27. What is the ratio of the Amount of stocks(% of population) of Caribbean small states in 1990 to that in 1995?
Offer a very short reply. 0.95. What is the ratio of the Amount of stocks(% of population) in Yemen, Rep. in 1990 to that in 1995?
Provide a short and direct response. 1.16. What is the ratio of the Amount of stocks(% of population) of Caribbean small states in 1990 to that in 2000?
Give a very brief answer. 0.93. What is the ratio of the Amount of stocks(% of population) in St. Lucia in 1990 to that in 2000?
Offer a terse response. 0.82. What is the ratio of the Amount of stocks(% of population) of Yemen, Rep. in 1990 to that in 2000?
Ensure brevity in your answer.  1.24. What is the ratio of the Amount of stocks(% of population) of Caribbean small states in 1990 to that in 2005?
Your response must be concise. 0.87. What is the ratio of the Amount of stocks(% of population) of St. Lucia in 1990 to that in 2005?
Your response must be concise. 0.74. What is the ratio of the Amount of stocks(% of population) of Yemen, Rep. in 1990 to that in 2005?
Give a very brief answer. 1.29. What is the ratio of the Amount of stocks(% of population) of Caribbean small states in 1995 to that in 2000?
Your response must be concise. 0.98. What is the ratio of the Amount of stocks(% of population) of St. Lucia in 1995 to that in 2000?
Your answer should be compact. 0.91. What is the ratio of the Amount of stocks(% of population) in Yemen, Rep. in 1995 to that in 2000?
Ensure brevity in your answer.  1.07. What is the ratio of the Amount of stocks(% of population) in Caribbean small states in 1995 to that in 2005?
Give a very brief answer. 0.92. What is the ratio of the Amount of stocks(% of population) of St. Lucia in 1995 to that in 2005?
Offer a very short reply. 0.82. What is the ratio of the Amount of stocks(% of population) in Yemen, Rep. in 1995 to that in 2005?
Your response must be concise. 1.11. What is the ratio of the Amount of stocks(% of population) in Caribbean small states in 2000 to that in 2005?
Provide a short and direct response. 0.94. What is the ratio of the Amount of stocks(% of population) of St. Lucia in 2000 to that in 2005?
Your response must be concise. 0.9. What is the ratio of the Amount of stocks(% of population) of Yemen, Rep. in 2000 to that in 2005?
Your response must be concise. 1.05. What is the difference between the highest and the second highest Amount of stocks(% of population) of Caribbean small states?
Give a very brief answer. 0.04. What is the difference between the highest and the second highest Amount of stocks(% of population) in St. Lucia?
Give a very brief answer. 0.53. What is the difference between the highest and the second highest Amount of stocks(% of population) in Yemen, Rep.?
Ensure brevity in your answer.  0.01. What is the difference between the highest and the lowest Amount of stocks(% of population) of Caribbean small states?
Offer a very short reply. 0.63. What is the difference between the highest and the lowest Amount of stocks(% of population) in St. Lucia?
Give a very brief answer. 2.43. What is the difference between the highest and the lowest Amount of stocks(% of population) of Yemen, Rep.?
Make the answer very short. 1.01. 